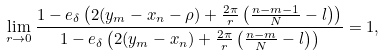<formula> <loc_0><loc_0><loc_500><loc_500>\lim _ { r \to 0 } \frac { 1 - e _ { \delta } \left ( 2 ( y _ { m } - x _ { n } - \rho ) + \frac { 2 \pi } { r } \left ( \frac { n - m - 1 } { N } - l \right ) \right ) } { 1 - e _ { \delta } \left ( 2 ( y _ { m } - x _ { n } ) + \frac { 2 \pi } { r } \left ( \frac { n - m } { N } - l \right ) \right ) } = 1 ,</formula> 